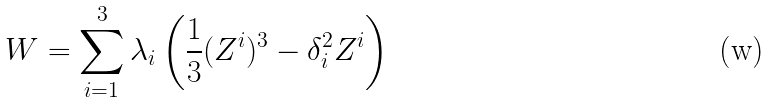Convert formula to latex. <formula><loc_0><loc_0><loc_500><loc_500>W = \sum _ { i = 1 } ^ { 3 } \lambda _ { i } \left ( \frac { 1 } { 3 } ( Z ^ { i } ) ^ { 3 } - \delta _ { i } ^ { 2 } Z ^ { i } \right )</formula> 